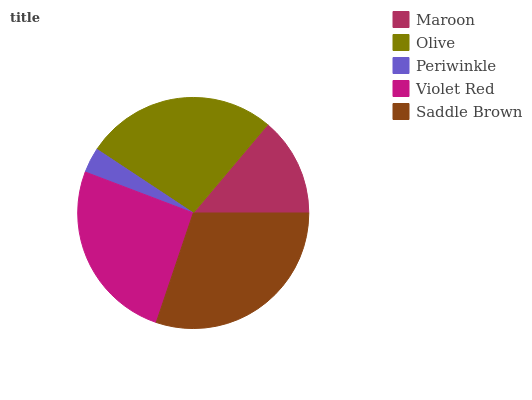Is Periwinkle the minimum?
Answer yes or no. Yes. Is Saddle Brown the maximum?
Answer yes or no. Yes. Is Olive the minimum?
Answer yes or no. No. Is Olive the maximum?
Answer yes or no. No. Is Olive greater than Maroon?
Answer yes or no. Yes. Is Maroon less than Olive?
Answer yes or no. Yes. Is Maroon greater than Olive?
Answer yes or no. No. Is Olive less than Maroon?
Answer yes or no. No. Is Violet Red the high median?
Answer yes or no. Yes. Is Violet Red the low median?
Answer yes or no. Yes. Is Maroon the high median?
Answer yes or no. No. Is Maroon the low median?
Answer yes or no. No. 